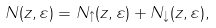Convert formula to latex. <formula><loc_0><loc_0><loc_500><loc_500>N ( z , \varepsilon ) = N _ { \uparrow } ( z , \varepsilon ) + N _ { \downarrow } ( z , \varepsilon ) ,</formula> 